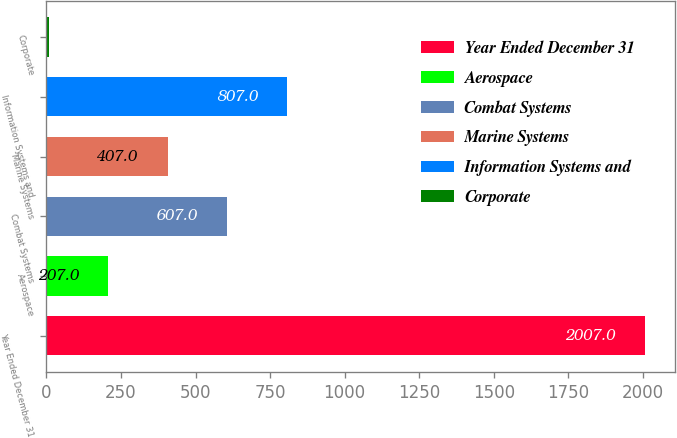Convert chart. <chart><loc_0><loc_0><loc_500><loc_500><bar_chart><fcel>Year Ended December 31<fcel>Aerospace<fcel>Combat Systems<fcel>Marine Systems<fcel>Information Systems and<fcel>Corporate<nl><fcel>2007<fcel>207<fcel>607<fcel>407<fcel>807<fcel>7<nl></chart> 